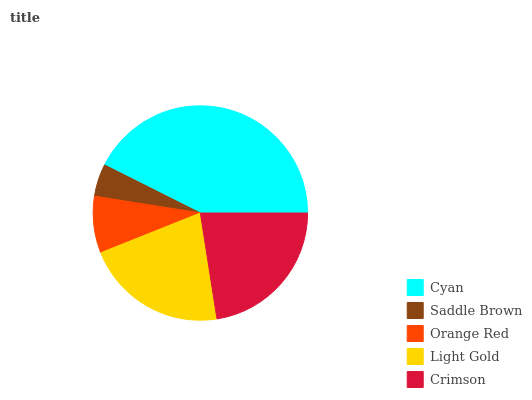Is Saddle Brown the minimum?
Answer yes or no. Yes. Is Cyan the maximum?
Answer yes or no. Yes. Is Orange Red the minimum?
Answer yes or no. No. Is Orange Red the maximum?
Answer yes or no. No. Is Orange Red greater than Saddle Brown?
Answer yes or no. Yes. Is Saddle Brown less than Orange Red?
Answer yes or no. Yes. Is Saddle Brown greater than Orange Red?
Answer yes or no. No. Is Orange Red less than Saddle Brown?
Answer yes or no. No. Is Light Gold the high median?
Answer yes or no. Yes. Is Light Gold the low median?
Answer yes or no. Yes. Is Cyan the high median?
Answer yes or no. No. Is Orange Red the low median?
Answer yes or no. No. 